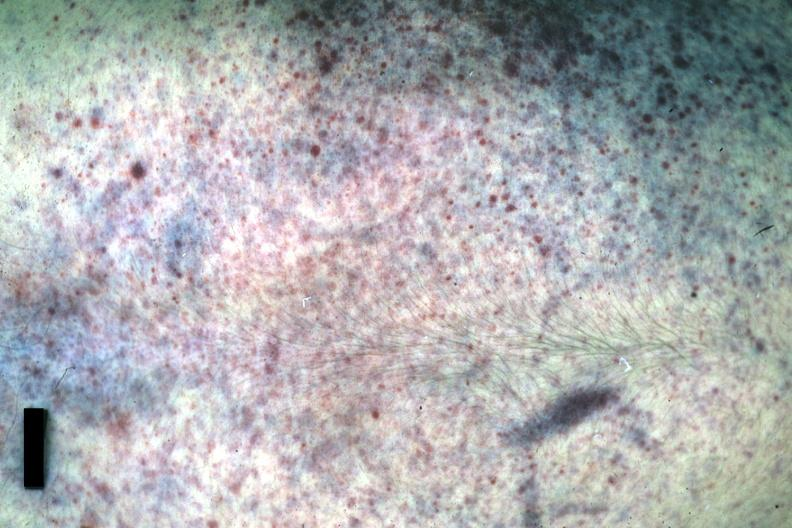what is present?
Answer the question using a single word or phrase. Petechiae 